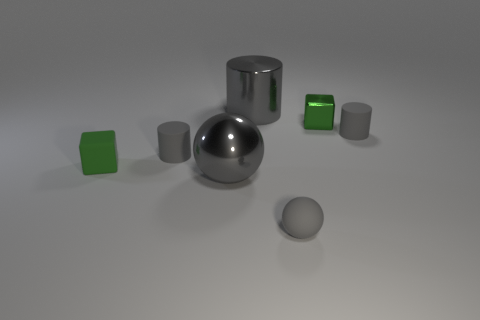What number of other objects are the same size as the gray metallic cylinder?
Offer a very short reply. 1. There is a matte cylinder that is to the left of the tiny sphere; how big is it?
Provide a succinct answer. Small. Is the green cube that is behind the green matte cube made of the same material as the small ball?
Your response must be concise. No. How many small objects are both behind the small gray sphere and on the right side of the metallic cylinder?
Provide a succinct answer. 2. There is a gray metallic thing right of the gray sphere left of the tiny gray ball; what is its size?
Provide a succinct answer. Large. Is the number of gray spheres greater than the number of big cyan matte things?
Your answer should be compact. Yes. Does the tiny cube behind the matte block have the same color as the small cube in front of the tiny green metallic cube?
Make the answer very short. Yes. Are there any large gray metal cylinders in front of the rubber object that is right of the small matte sphere?
Your response must be concise. No. Are there fewer big gray shiny cylinders in front of the small rubber block than gray rubber cylinders that are left of the large gray cylinder?
Keep it short and to the point. Yes. Does the cube behind the green rubber thing have the same material as the gray cylinder behind the small green shiny object?
Provide a succinct answer. Yes. 